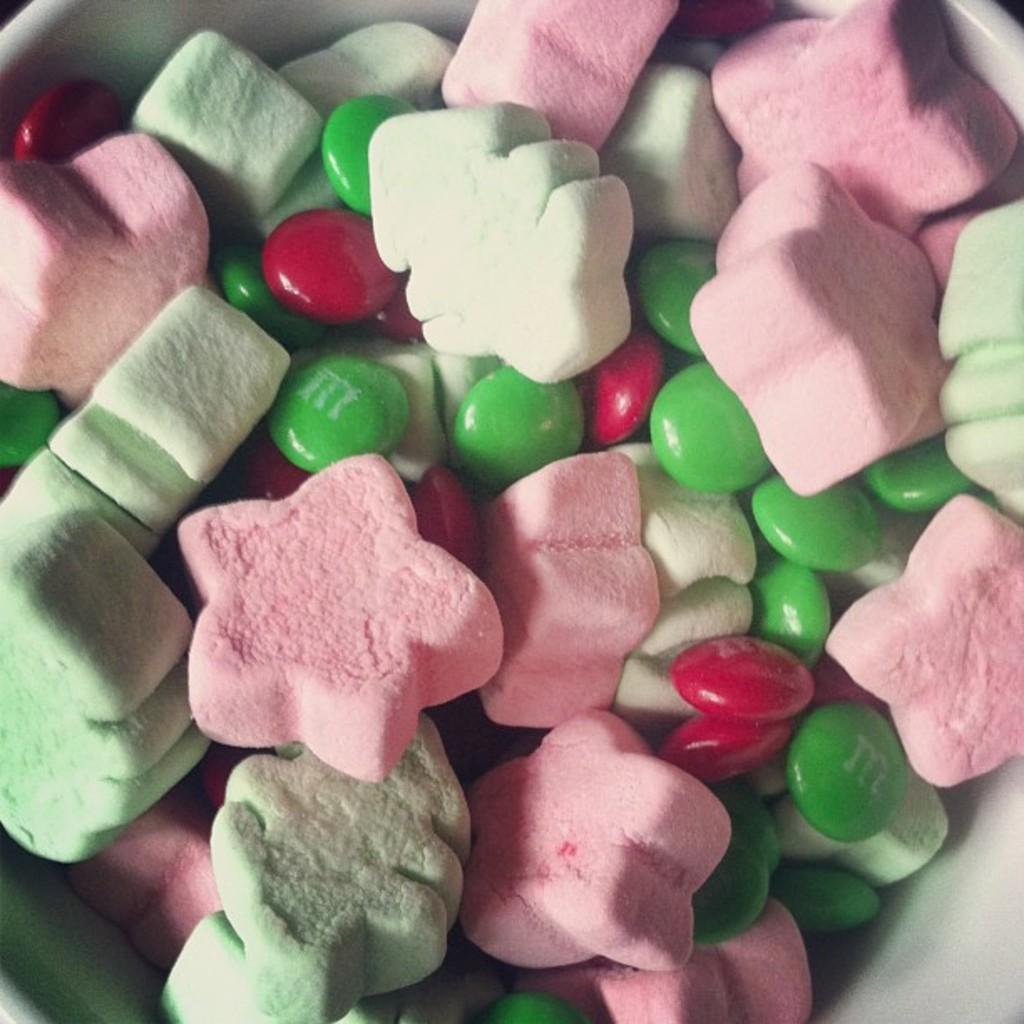Can you describe this image briefly? In this image in the middle, there is a bowl on that there are many candies and marshmallows. 